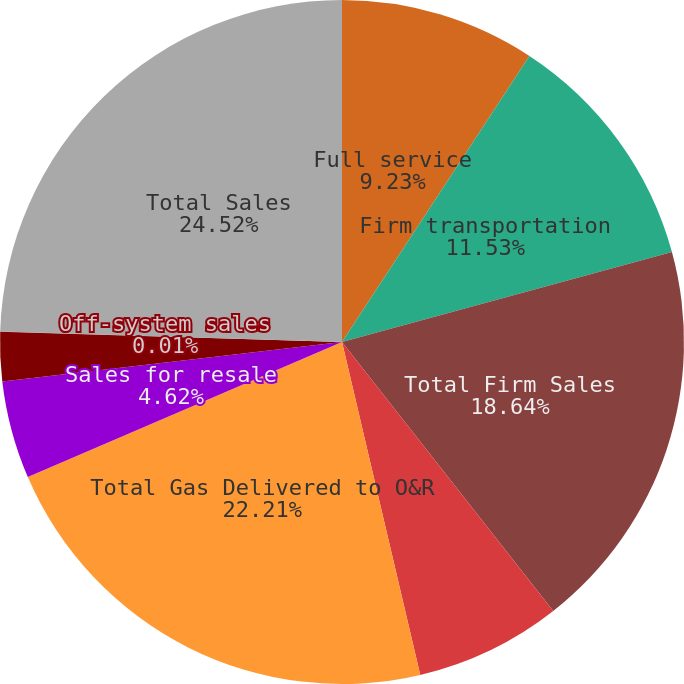Convert chart. <chart><loc_0><loc_0><loc_500><loc_500><pie_chart><fcel>Full service<fcel>Firm transportation<fcel>Total Firm Sales<fcel>Interruptible sales<fcel>Total Gas Delivered to O&R<fcel>Sales for resale<fcel>Sales to electric generating<fcel>Off-system sales<fcel>Total Sales<nl><fcel>9.23%<fcel>11.53%<fcel>18.64%<fcel>6.92%<fcel>22.21%<fcel>4.62%<fcel>2.32%<fcel>0.01%<fcel>24.51%<nl></chart> 